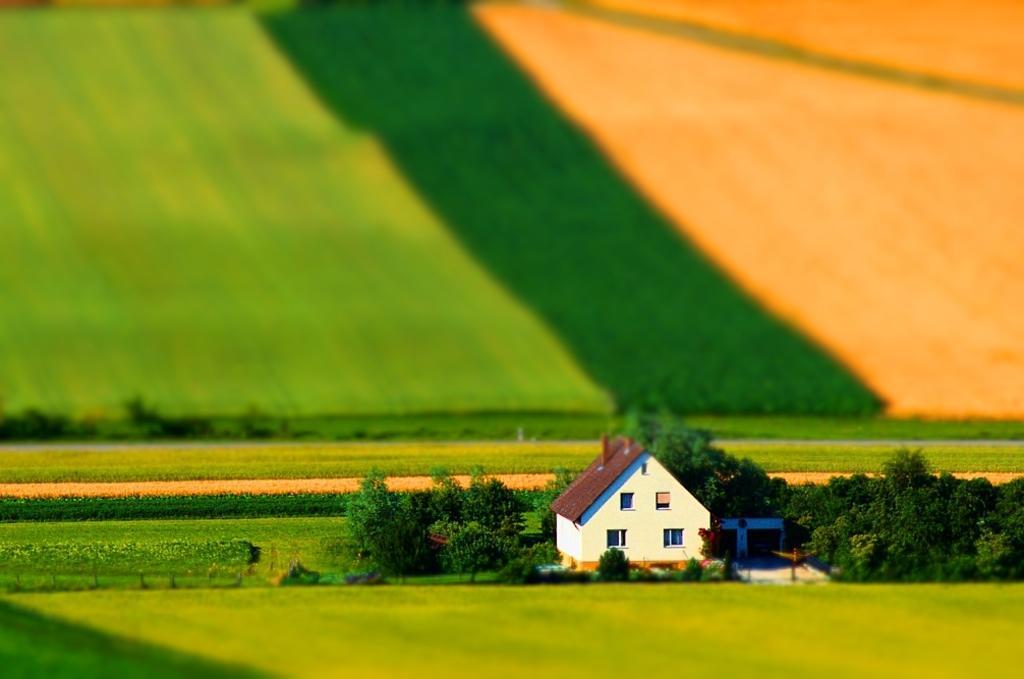Can you describe this image briefly? In this picture we can see small shed house in the middle of the image. Beside there are some trees. Behind we can see the farm. 